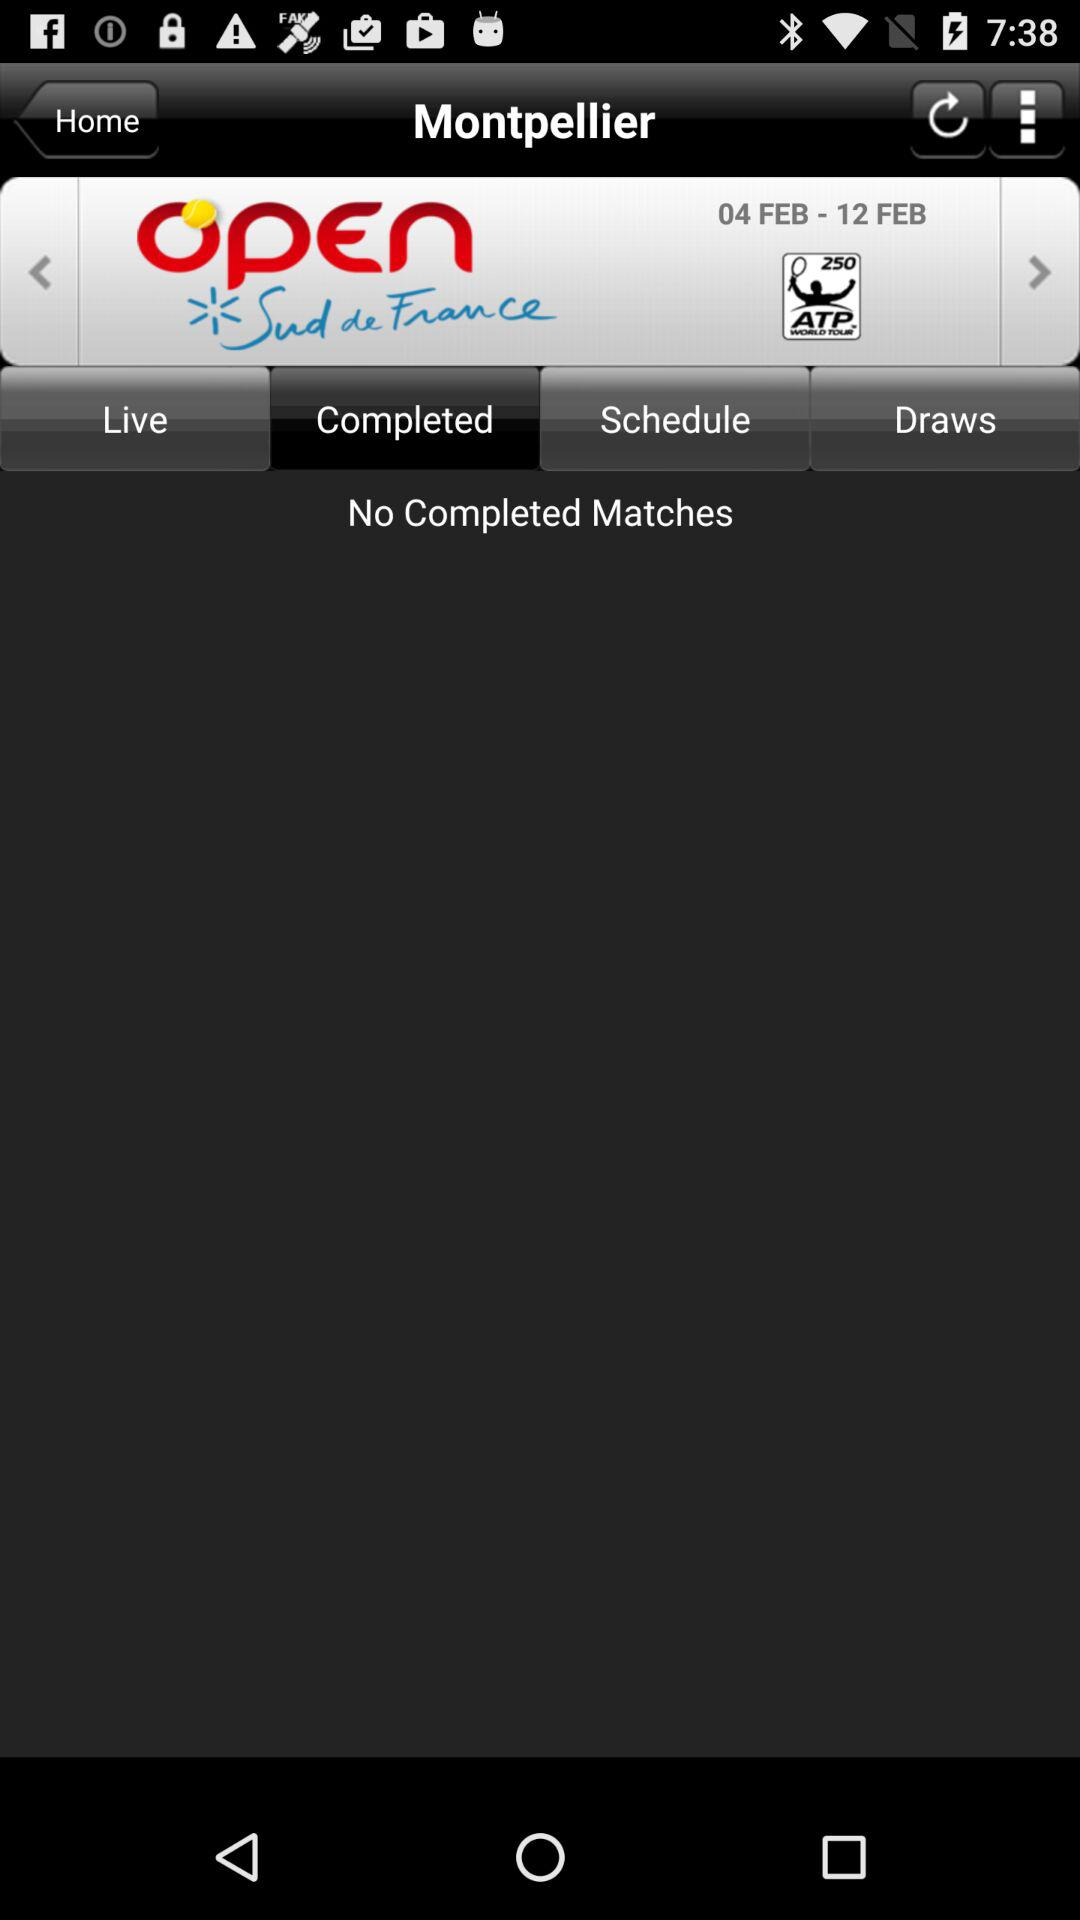Which tab is selected? The selected tab is "Completed". 